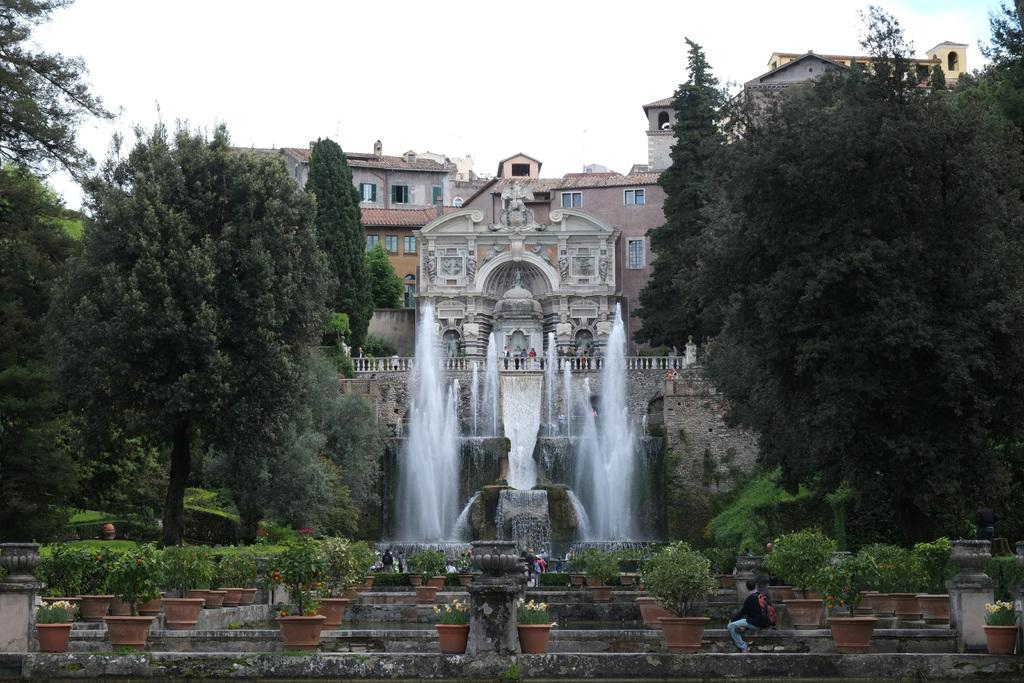What is placed on the stone surface in the foreground of the image? There are plants placed on a stone surface in the foreground. What can be seen in the middle of the image? There are trees and a fountain in the middle of the image. What type of structure is visible in the background? There are buildings in the background. What is visible in the sky in the background of the image? The sky is visible in the background of the image. What type of learning is taking place in the image? There is no indication of learning taking place in the image. What action is being performed by the trees in the image? Trees are stationary objects and do not perform actions in the image. 